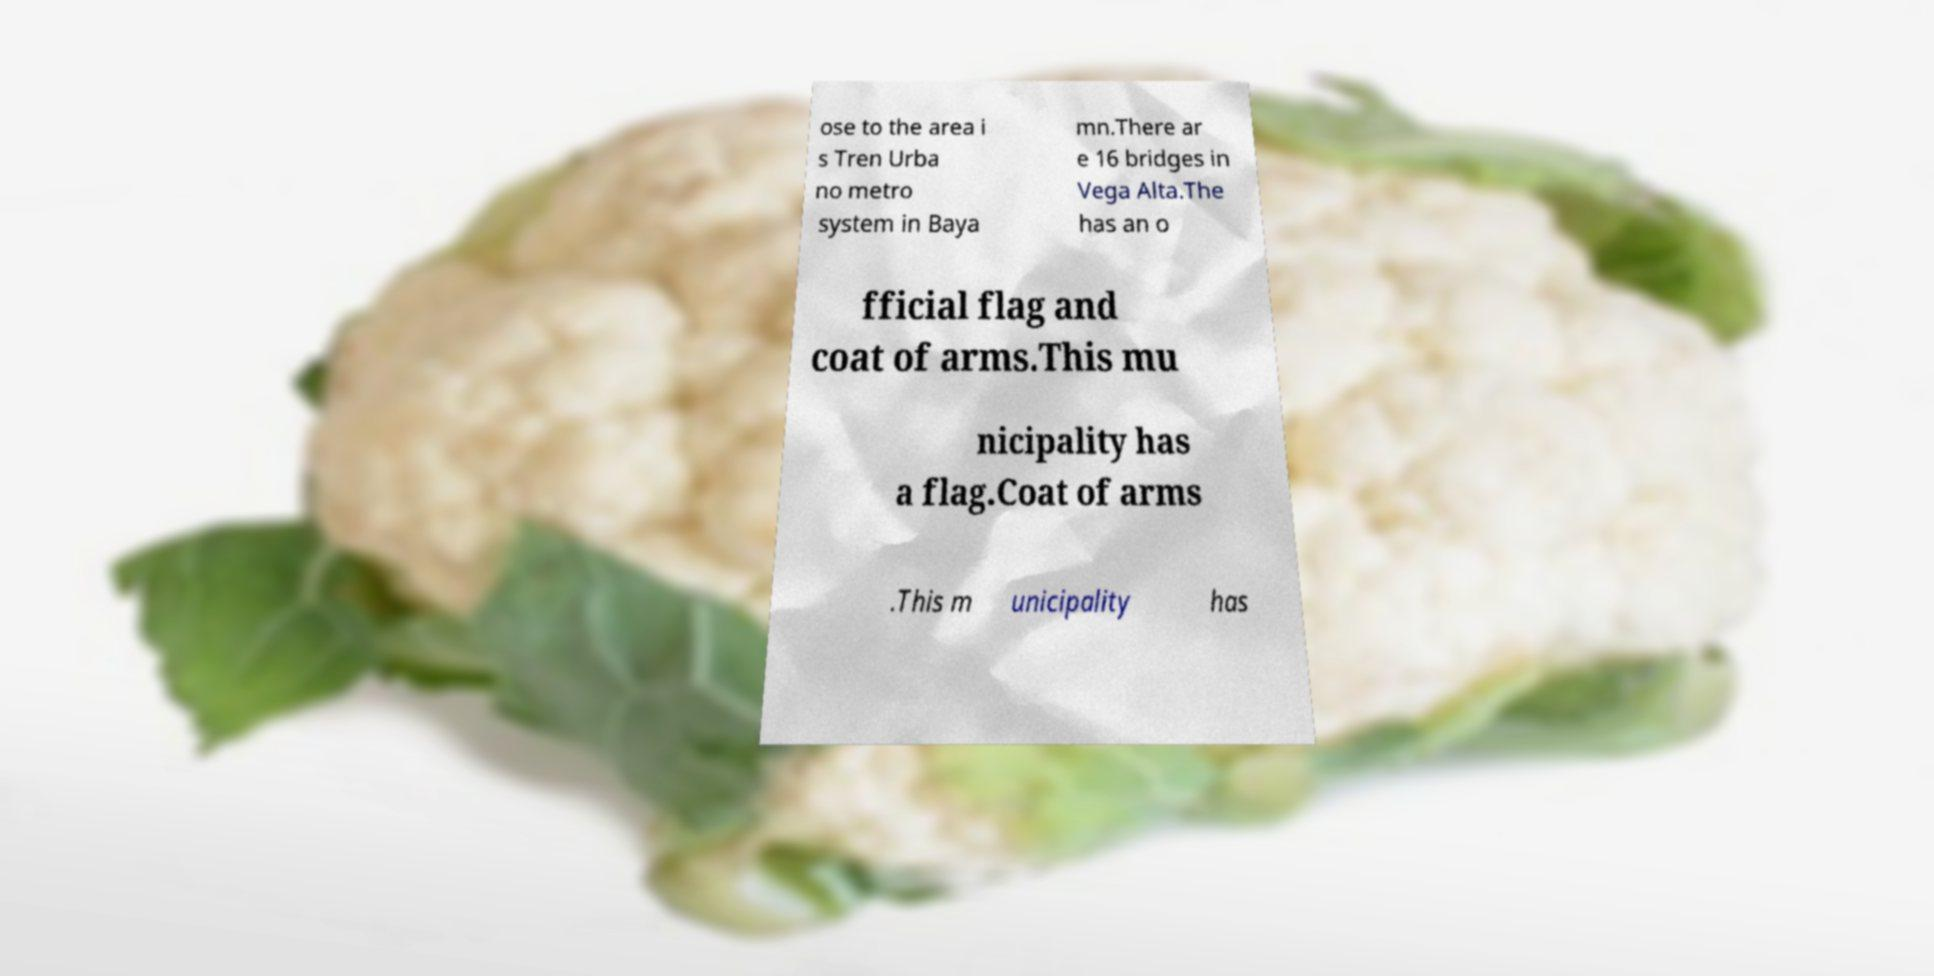What messages or text are displayed in this image? I need them in a readable, typed format. ose to the area i s Tren Urba no metro system in Baya mn.There ar e 16 bridges in Vega Alta.The has an o fficial flag and coat of arms.This mu nicipality has a flag.Coat of arms .This m unicipality has 